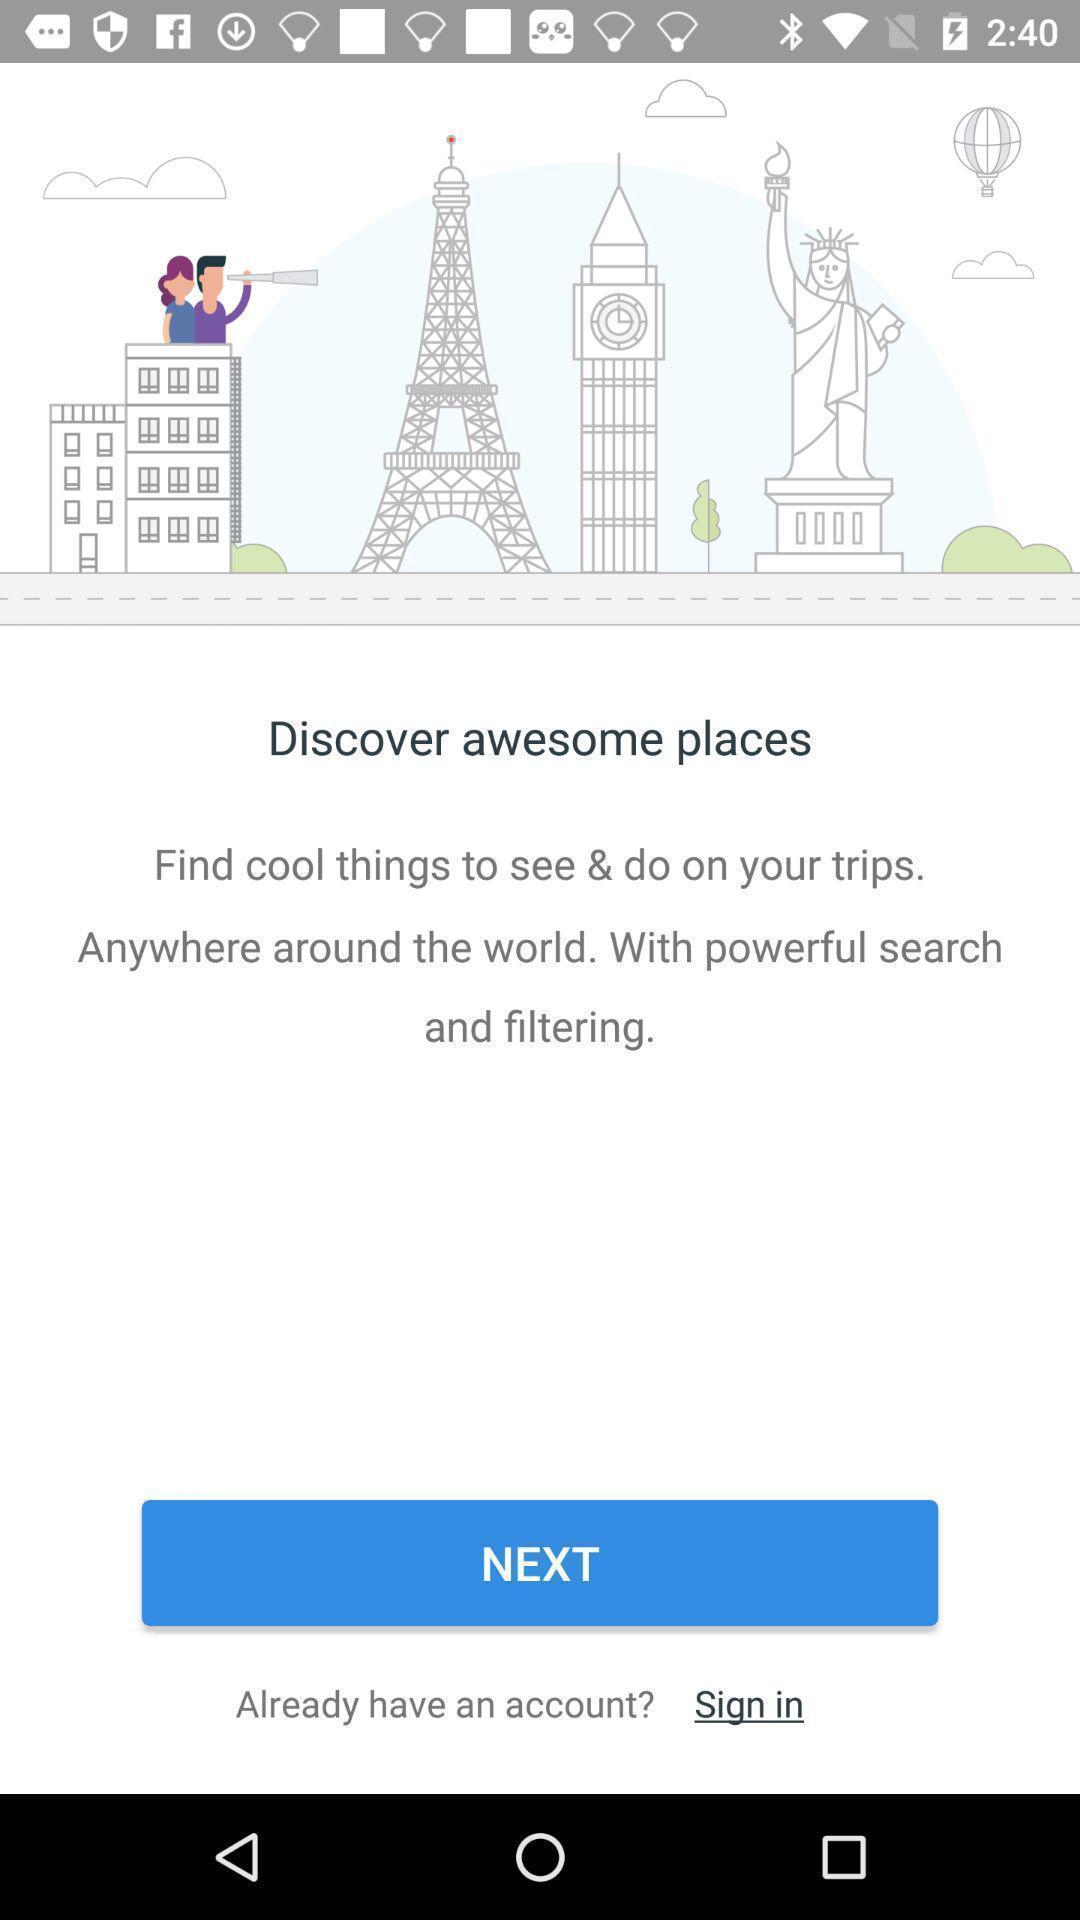Tell me about the visual elements in this screen capture. Welcome page. 